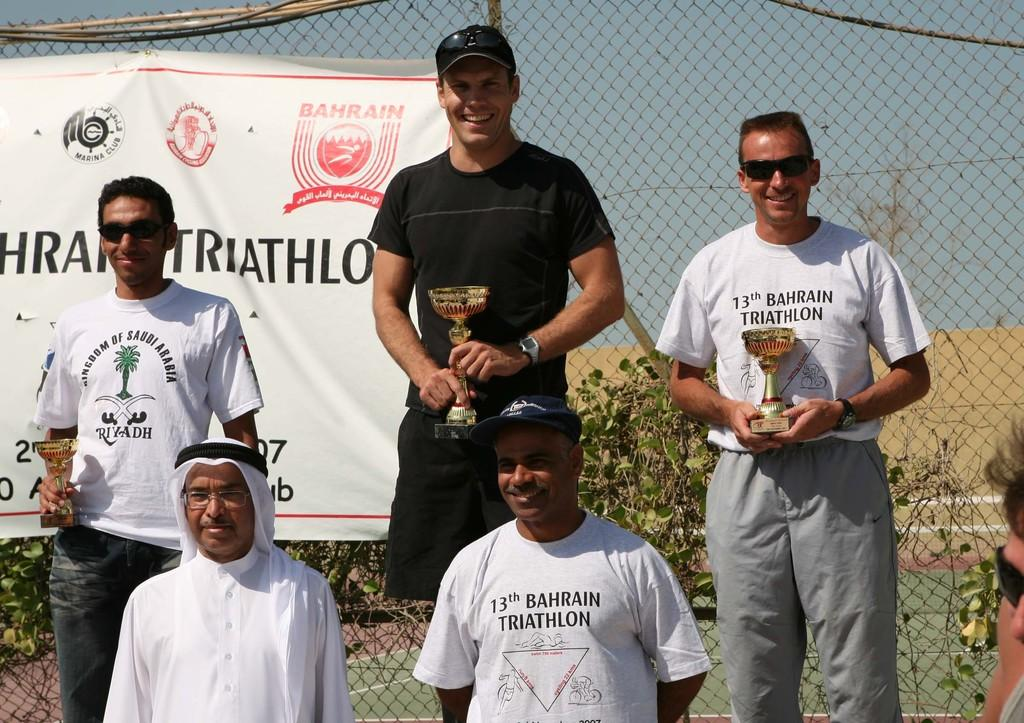<image>
Share a concise interpretation of the image provided. Group of men taking a picture holding trophies including one with a shirt that says "13th Bahrain Triathlon". 